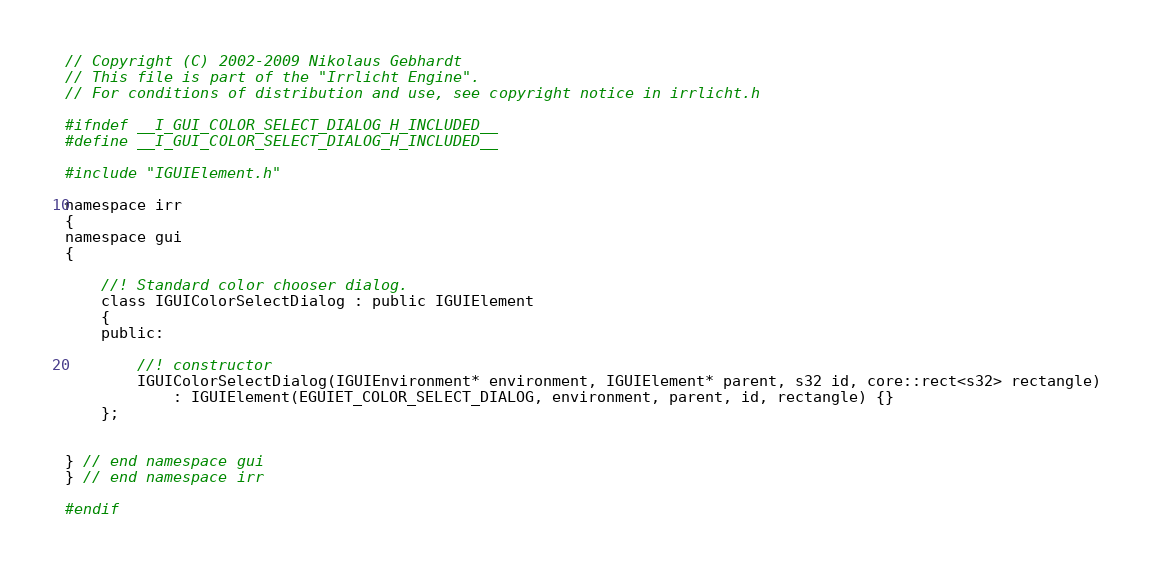<code> <loc_0><loc_0><loc_500><loc_500><_C_>// Copyright (C) 2002-2009 Nikolaus Gebhardt
// This file is part of the "Irrlicht Engine".
// For conditions of distribution and use, see copyright notice in irrlicht.h

#ifndef __I_GUI_COLOR_SELECT_DIALOG_H_INCLUDED__
#define __I_GUI_COLOR_SELECT_DIALOG_H_INCLUDED__

#include "IGUIElement.h"

namespace irr
{
namespace gui
{

	//! Standard color chooser dialog.
	class IGUIColorSelectDialog : public IGUIElement
	{
	public:

		//! constructor
		IGUIColorSelectDialog(IGUIEnvironment* environment, IGUIElement* parent, s32 id, core::rect<s32> rectangle)
			: IGUIElement(EGUIET_COLOR_SELECT_DIALOG, environment, parent, id, rectangle) {}
	};


} // end namespace gui
} // end namespace irr

#endif

</code> 